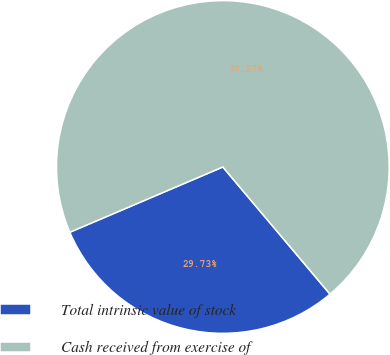<chart> <loc_0><loc_0><loc_500><loc_500><pie_chart><fcel>Total intrinsic value of stock<fcel>Cash received from exercise of<nl><fcel>29.73%<fcel>70.27%<nl></chart> 